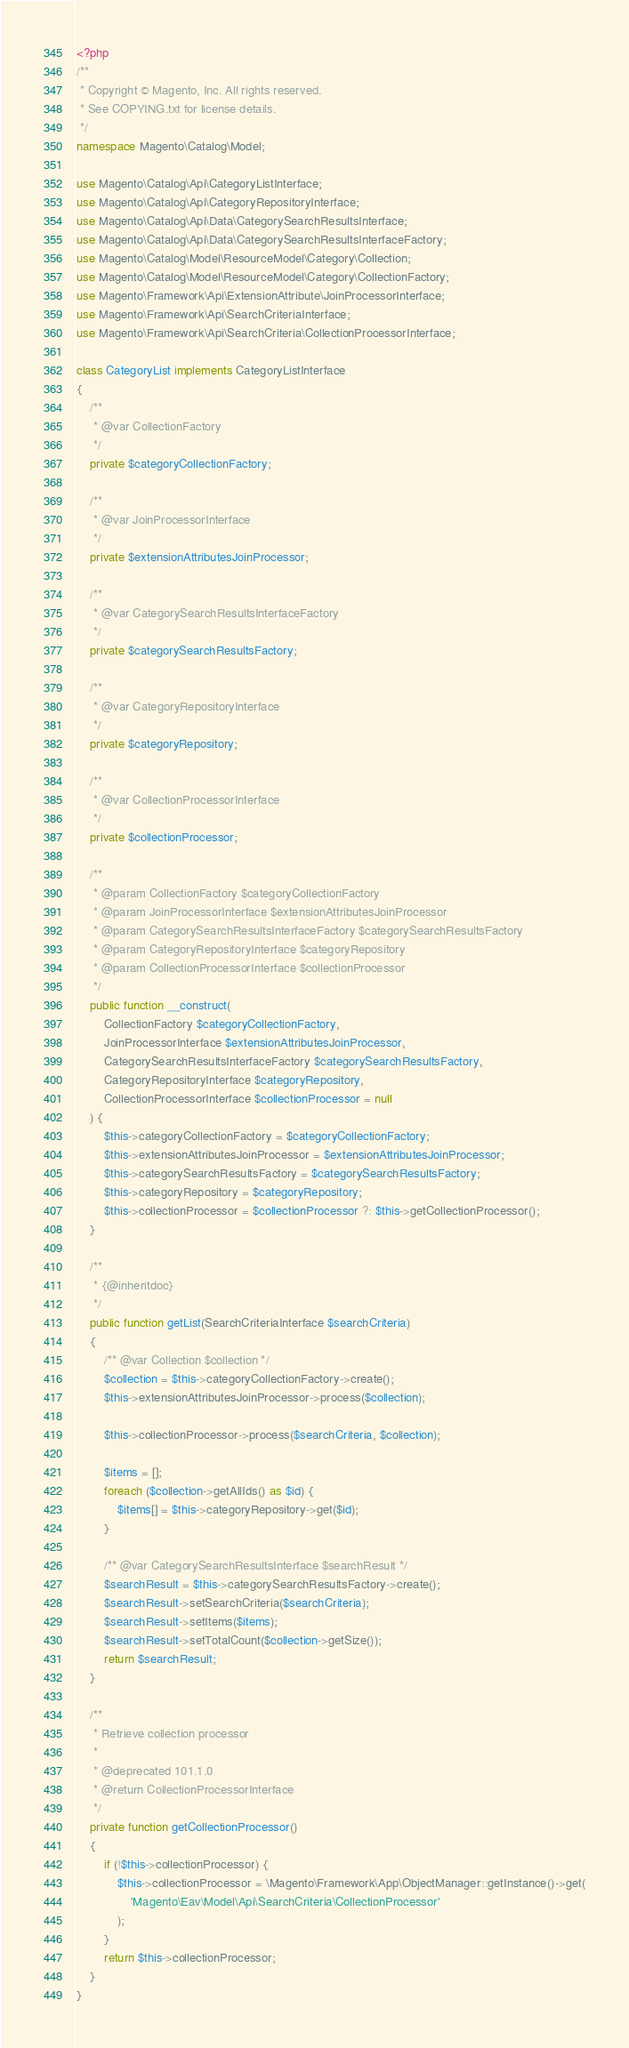Convert code to text. <code><loc_0><loc_0><loc_500><loc_500><_PHP_><?php
/**
 * Copyright © Magento, Inc. All rights reserved.
 * See COPYING.txt for license details.
 */
namespace Magento\Catalog\Model;

use Magento\Catalog\Api\CategoryListInterface;
use Magento\Catalog\Api\CategoryRepositoryInterface;
use Magento\Catalog\Api\Data\CategorySearchResultsInterface;
use Magento\Catalog\Api\Data\CategorySearchResultsInterfaceFactory;
use Magento\Catalog\Model\ResourceModel\Category\Collection;
use Magento\Catalog\Model\ResourceModel\Category\CollectionFactory;
use Magento\Framework\Api\ExtensionAttribute\JoinProcessorInterface;
use Magento\Framework\Api\SearchCriteriaInterface;
use Magento\Framework\Api\SearchCriteria\CollectionProcessorInterface;

class CategoryList implements CategoryListInterface
{
    /**
     * @var CollectionFactory
     */
    private $categoryCollectionFactory;

    /**
     * @var JoinProcessorInterface
     */
    private $extensionAttributesJoinProcessor;

    /**
     * @var CategorySearchResultsInterfaceFactory
     */
    private $categorySearchResultsFactory;

    /**
     * @var CategoryRepositoryInterface
     */
    private $categoryRepository;

    /**
     * @var CollectionProcessorInterface
     */
    private $collectionProcessor;

    /**
     * @param CollectionFactory $categoryCollectionFactory
     * @param JoinProcessorInterface $extensionAttributesJoinProcessor
     * @param CategorySearchResultsInterfaceFactory $categorySearchResultsFactory
     * @param CategoryRepositoryInterface $categoryRepository
     * @param CollectionProcessorInterface $collectionProcessor
     */
    public function __construct(
        CollectionFactory $categoryCollectionFactory,
        JoinProcessorInterface $extensionAttributesJoinProcessor,
        CategorySearchResultsInterfaceFactory $categorySearchResultsFactory,
        CategoryRepositoryInterface $categoryRepository,
        CollectionProcessorInterface $collectionProcessor = null
    ) {
        $this->categoryCollectionFactory = $categoryCollectionFactory;
        $this->extensionAttributesJoinProcessor = $extensionAttributesJoinProcessor;
        $this->categorySearchResultsFactory = $categorySearchResultsFactory;
        $this->categoryRepository = $categoryRepository;
        $this->collectionProcessor = $collectionProcessor ?: $this->getCollectionProcessor();
    }

    /**
     * {@inheritdoc}
     */
    public function getList(SearchCriteriaInterface $searchCriteria)
    {
        /** @var Collection $collection */
        $collection = $this->categoryCollectionFactory->create();
        $this->extensionAttributesJoinProcessor->process($collection);

        $this->collectionProcessor->process($searchCriteria, $collection);

        $items = [];
        foreach ($collection->getAllIds() as $id) {
            $items[] = $this->categoryRepository->get($id);
        }

        /** @var CategorySearchResultsInterface $searchResult */
        $searchResult = $this->categorySearchResultsFactory->create();
        $searchResult->setSearchCriteria($searchCriteria);
        $searchResult->setItems($items);
        $searchResult->setTotalCount($collection->getSize());
        return $searchResult;
    }

    /**
     * Retrieve collection processor
     *
     * @deprecated 101.1.0
     * @return CollectionProcessorInterface
     */
    private function getCollectionProcessor()
    {
        if (!$this->collectionProcessor) {
            $this->collectionProcessor = \Magento\Framework\App\ObjectManager::getInstance()->get(
                'Magento\Eav\Model\Api\SearchCriteria\CollectionProcessor'
            );
        }
        return $this->collectionProcessor;
    }
}
</code> 